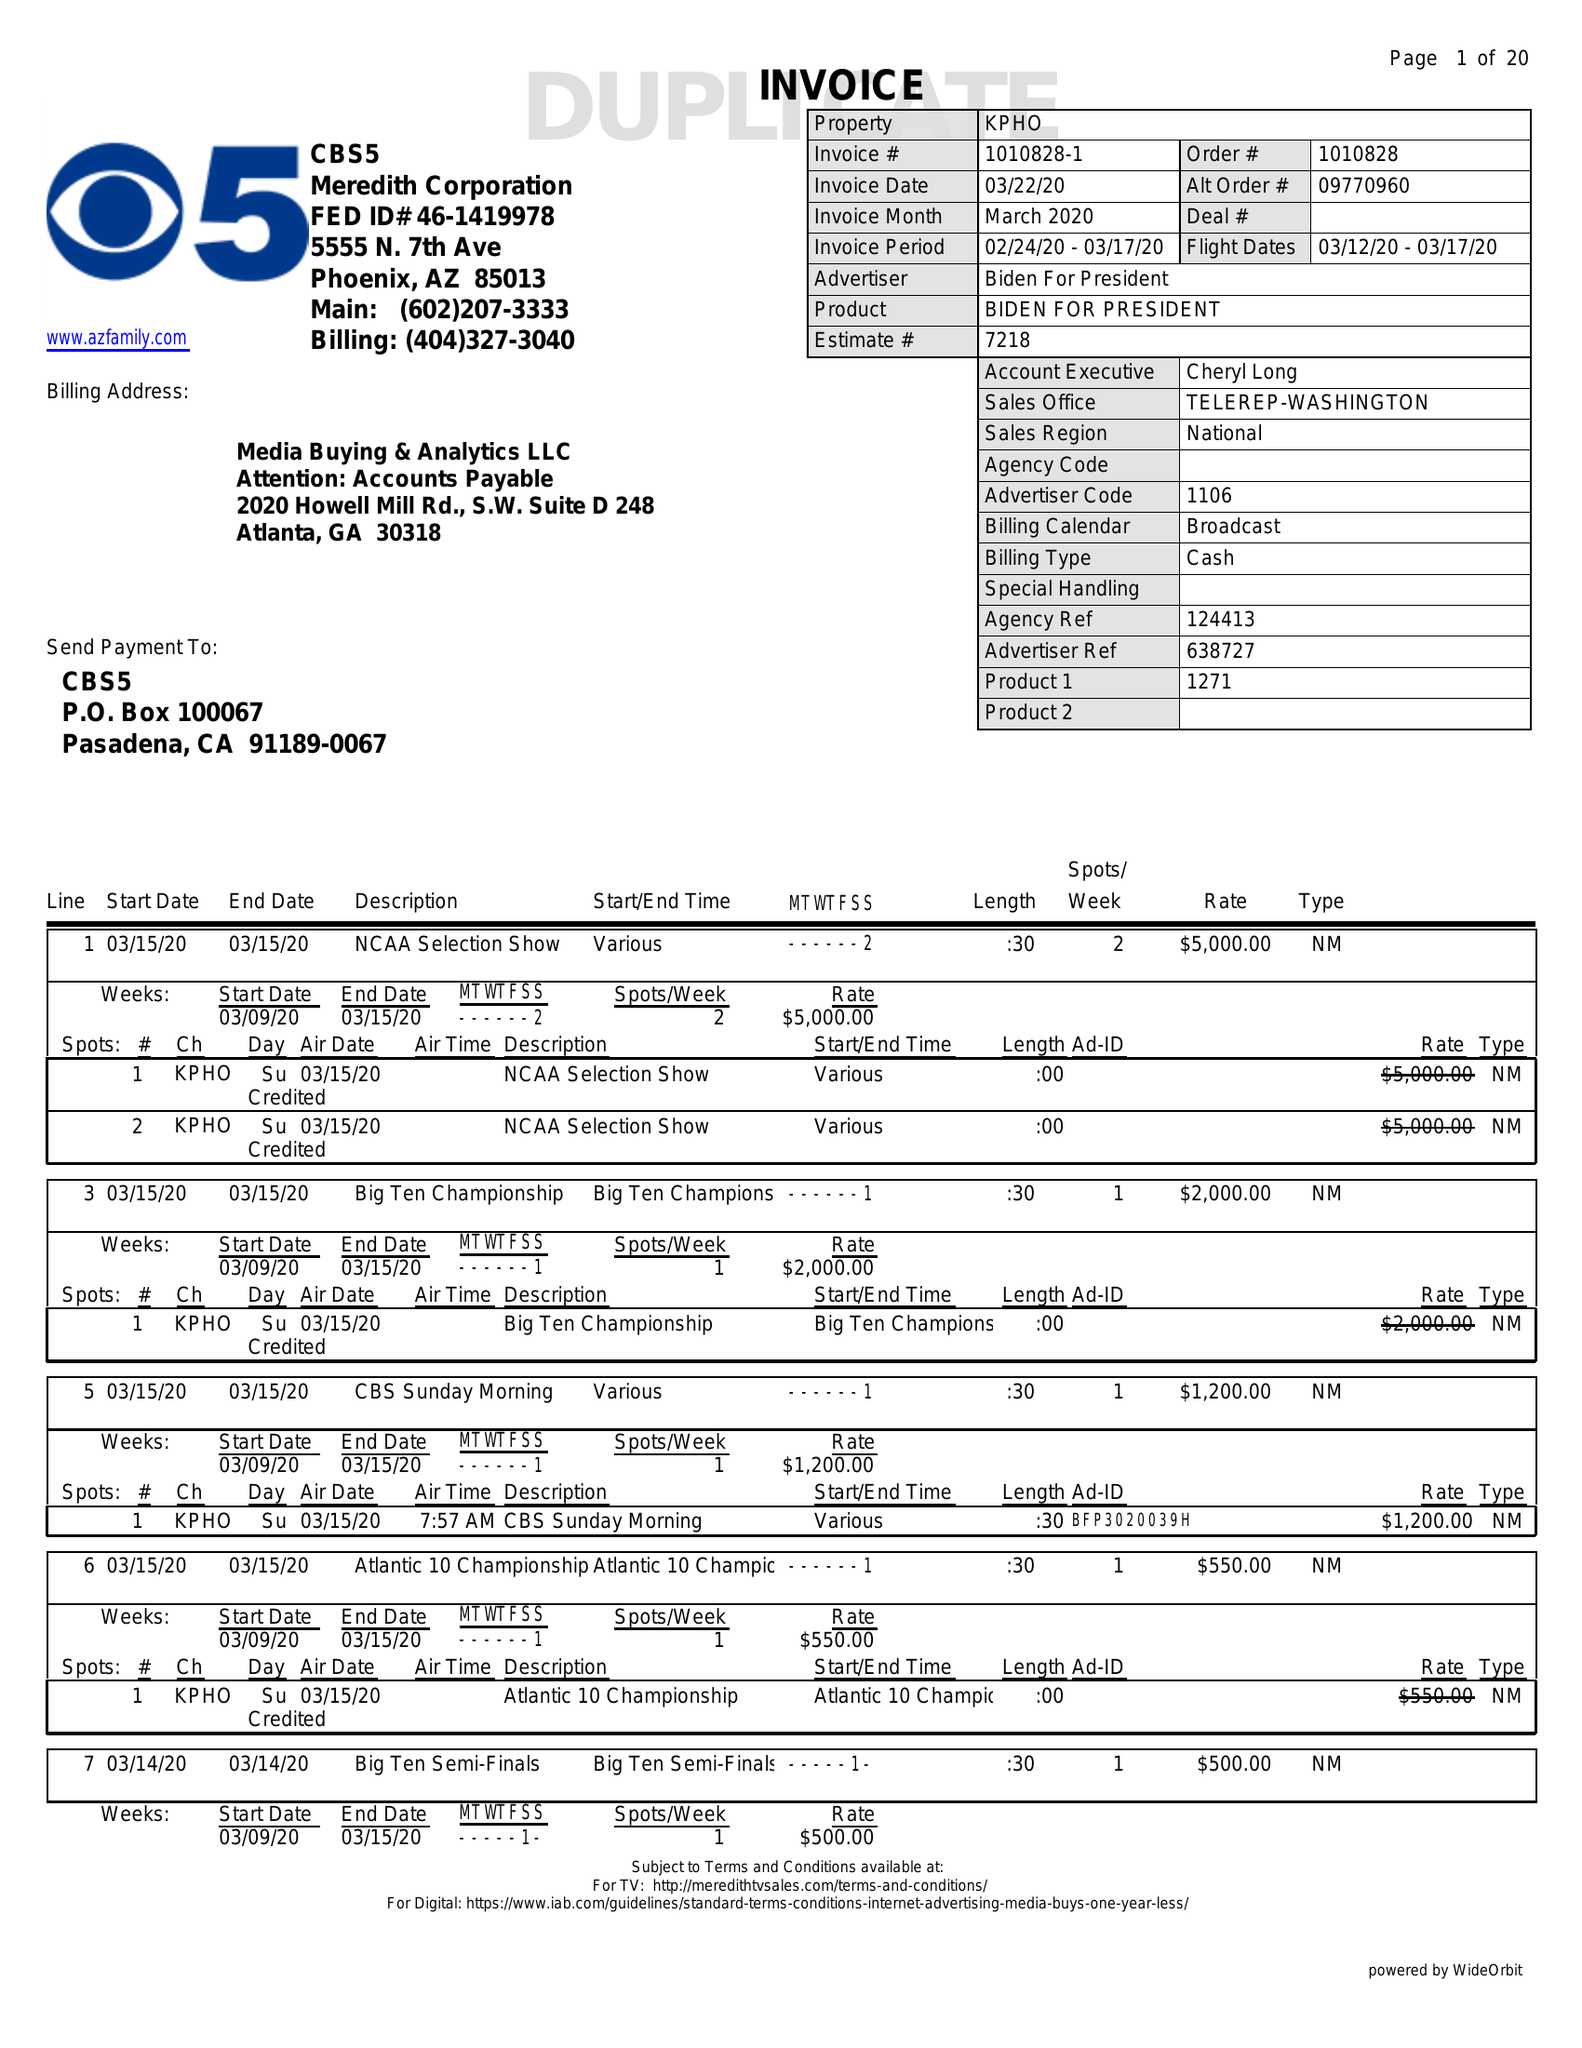What is the value for the contract_num?
Answer the question using a single word or phrase. 1010828 